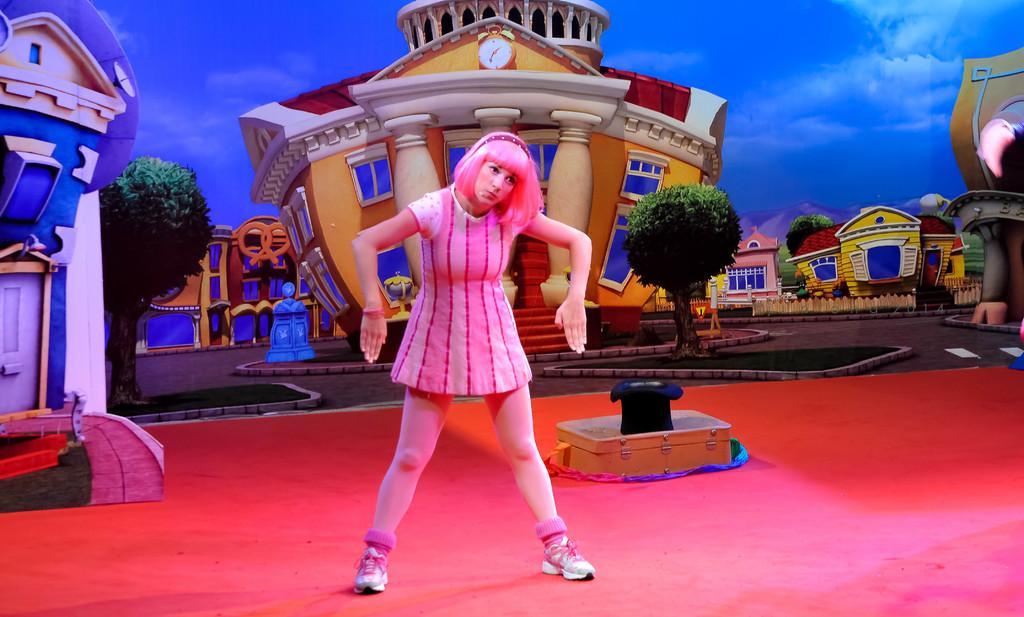Could you give a brief overview of what you see in this image? There is a lady standing on a stage. On the stage there is a box. In the back there is a wall with a building, trees, grass lawn and a sky with clouds. Also there is a clock on the building 